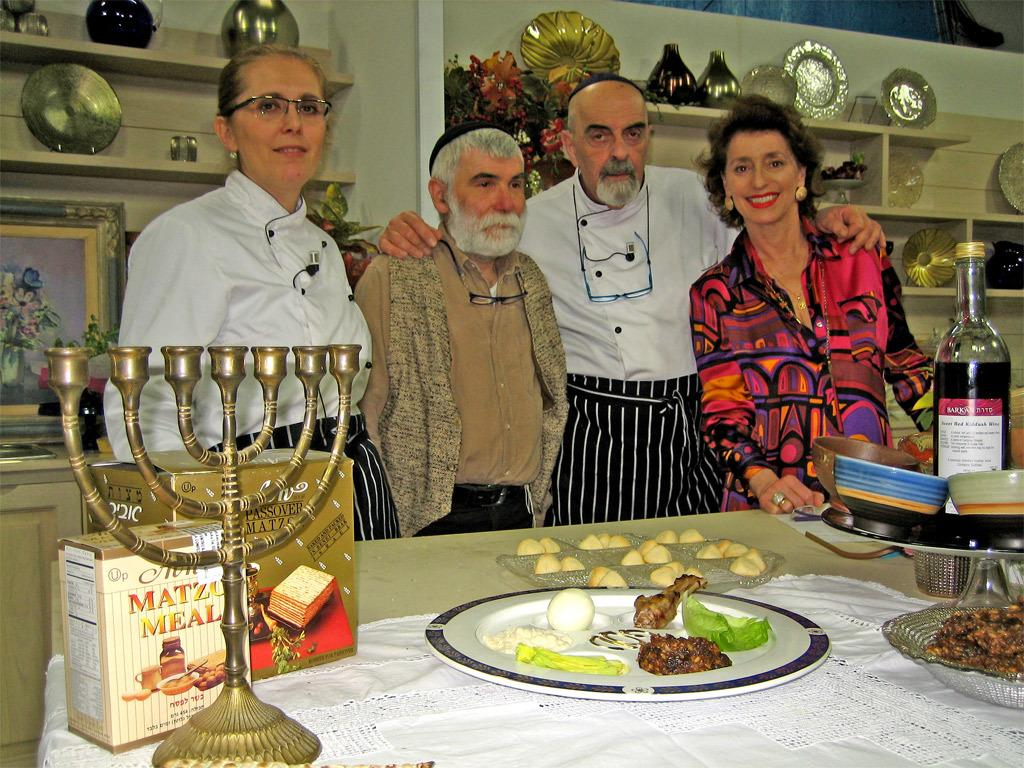Who or what can be seen in the image? There are people in the image. What else is visible in the image besides the people? There are food items on a table and a shelf in the background of the image. What type of stitch is being used to hold the tub together in the image? There is no tub present in the image, so it is not possible to determine what type of stitch might be used to hold it together. 